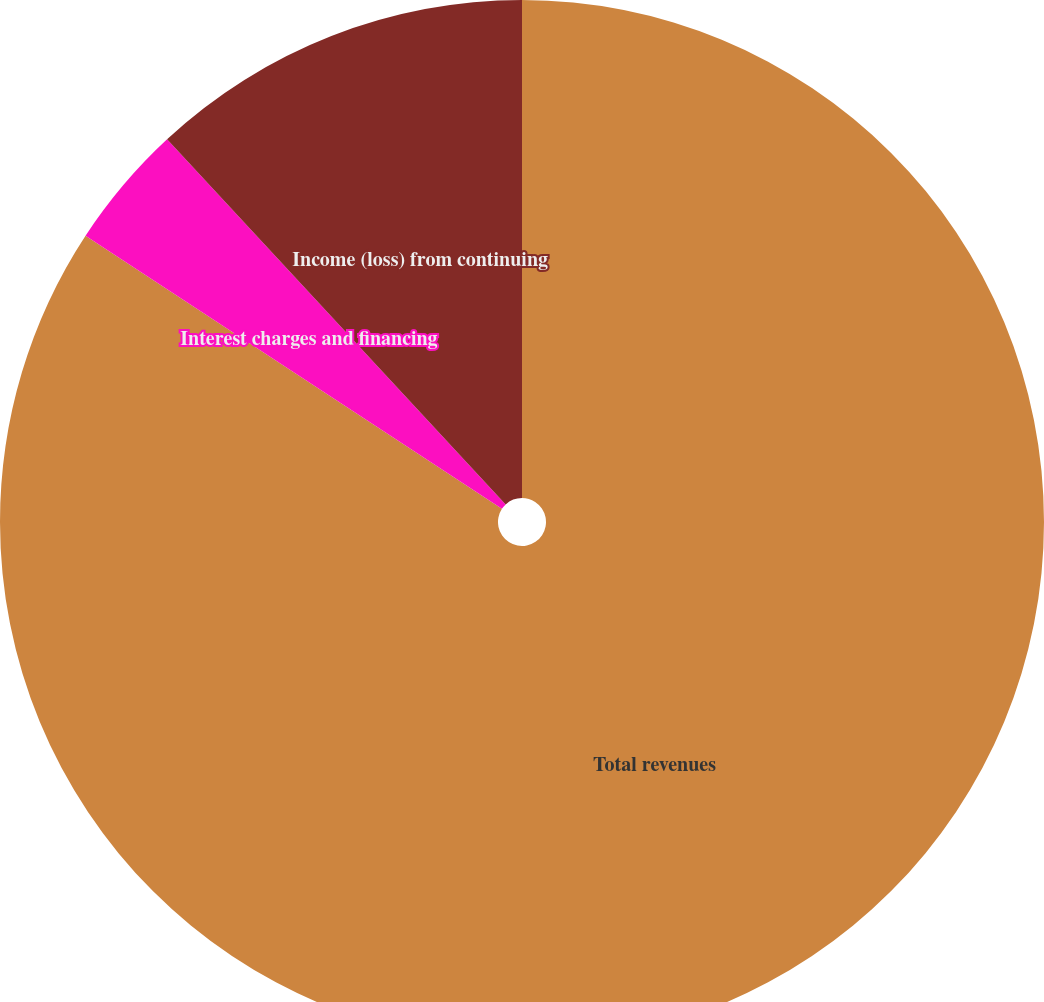<chart> <loc_0><loc_0><loc_500><loc_500><pie_chart><fcel>Total revenues<fcel>Interest charges and financing<fcel>Income (loss) from continuing<nl><fcel>84.24%<fcel>3.86%<fcel>11.9%<nl></chart> 